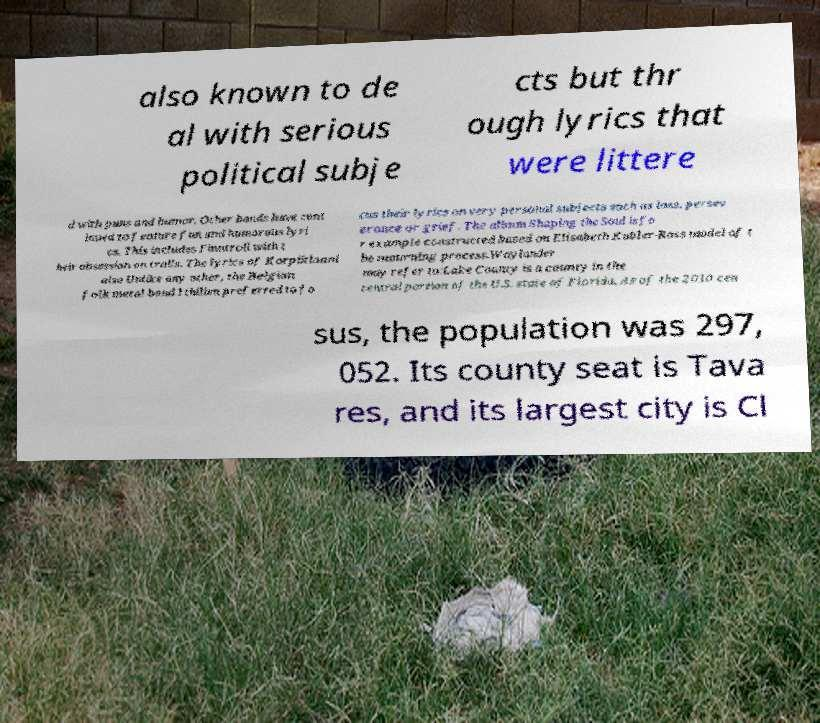Can you read and provide the text displayed in the image?This photo seems to have some interesting text. Can you extract and type it out for me? also known to de al with serious political subje cts but thr ough lyrics that were littere d with puns and humor. Other bands have cont inued to feature fun and humorous lyri cs. This includes Finntroll with t heir obsession on trolls. The lyrics of Korpiklaani also Unlike any other, the Belgian folk metal band Ithilien preferred to fo cus their lyrics on very personal subjects such as loss, persev erance or grief. The album Shaping the Soul is fo r example constructed based on Elisabeth Kubler-Ross model of t he mourning process.Waylander may refer to:Lake County is a county in the central portion of the U.S. state of Florida. As of the 2010 cen sus, the population was 297, 052. Its county seat is Tava res, and its largest city is Cl 